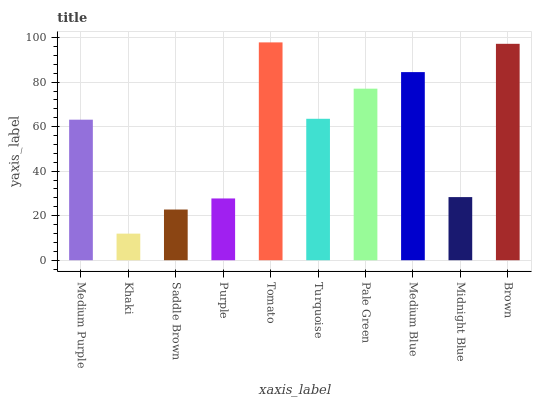Is Khaki the minimum?
Answer yes or no. Yes. Is Tomato the maximum?
Answer yes or no. Yes. Is Saddle Brown the minimum?
Answer yes or no. No. Is Saddle Brown the maximum?
Answer yes or no. No. Is Saddle Brown greater than Khaki?
Answer yes or no. Yes. Is Khaki less than Saddle Brown?
Answer yes or no. Yes. Is Khaki greater than Saddle Brown?
Answer yes or no. No. Is Saddle Brown less than Khaki?
Answer yes or no. No. Is Turquoise the high median?
Answer yes or no. Yes. Is Medium Purple the low median?
Answer yes or no. Yes. Is Pale Green the high median?
Answer yes or no. No. Is Tomato the low median?
Answer yes or no. No. 